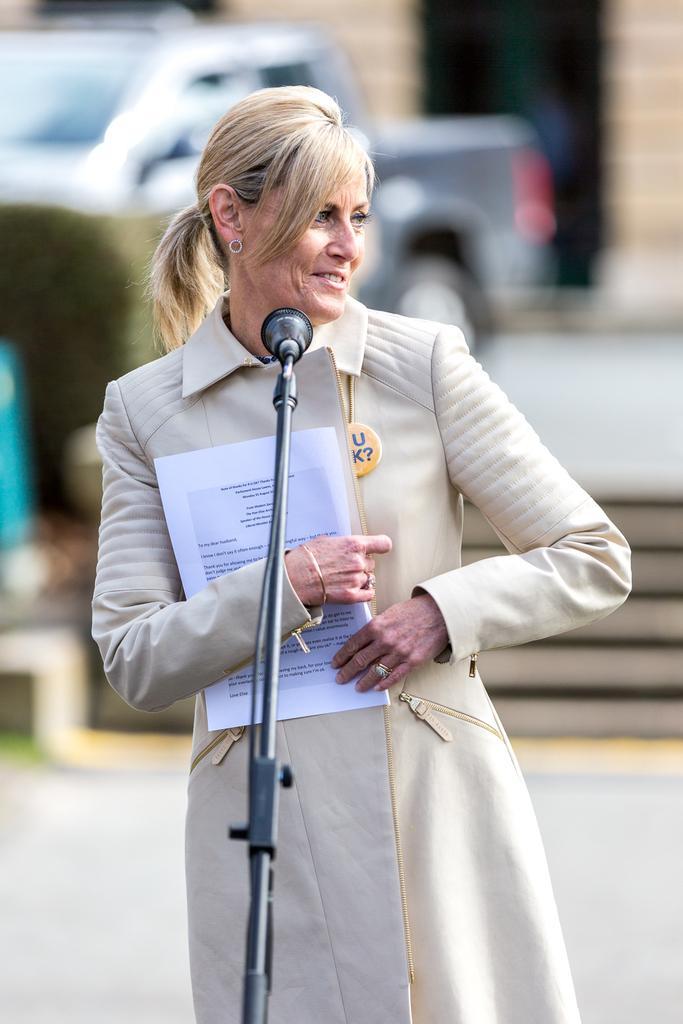Describe this image in one or two sentences. In the foreground I can see a woman is standing in front of a mike and is holding papers in hand. In the background I can see a vehicle, steps, grass, tree and a door in a building. This image is taken may be during a day. 